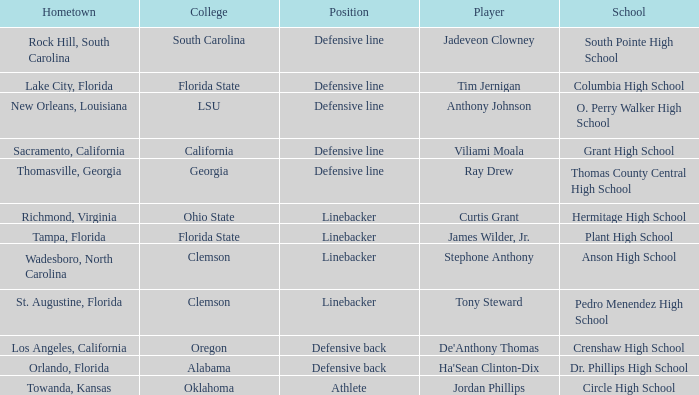Which player is from Tampa, Florida? James Wilder, Jr. 